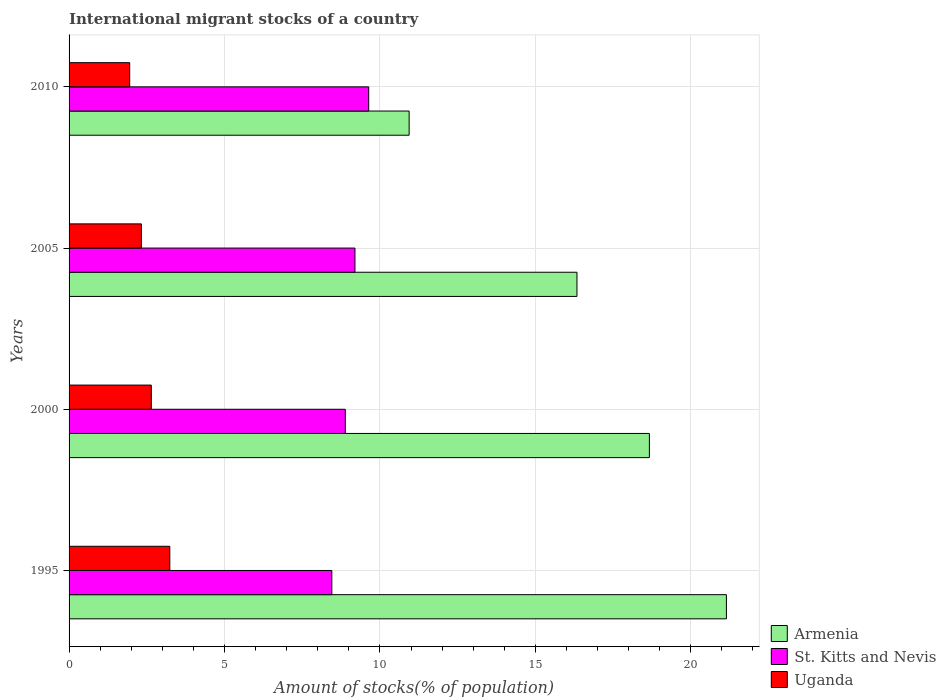How many different coloured bars are there?
Keep it short and to the point. 3. Are the number of bars per tick equal to the number of legend labels?
Keep it short and to the point. Yes. Are the number of bars on each tick of the Y-axis equal?
Provide a short and direct response. Yes. How many bars are there on the 3rd tick from the top?
Your answer should be very brief. 3. How many bars are there on the 3rd tick from the bottom?
Offer a very short reply. 3. What is the amount of stocks in in St. Kitts and Nevis in 1995?
Your answer should be very brief. 8.45. Across all years, what is the maximum amount of stocks in in St. Kitts and Nevis?
Offer a very short reply. 9.64. Across all years, what is the minimum amount of stocks in in Uganda?
Your response must be concise. 1.95. In which year was the amount of stocks in in Armenia minimum?
Give a very brief answer. 2010. What is the total amount of stocks in in St. Kitts and Nevis in the graph?
Offer a terse response. 36.17. What is the difference between the amount of stocks in in St. Kitts and Nevis in 2000 and that in 2010?
Keep it short and to the point. -0.75. What is the difference between the amount of stocks in in St. Kitts and Nevis in 2005 and the amount of stocks in in Uganda in 1995?
Give a very brief answer. 5.96. What is the average amount of stocks in in Armenia per year?
Your answer should be very brief. 16.77. In the year 1995, what is the difference between the amount of stocks in in Armenia and amount of stocks in in St. Kitts and Nevis?
Your answer should be compact. 12.69. What is the ratio of the amount of stocks in in St. Kitts and Nevis in 2005 to that in 2010?
Give a very brief answer. 0.95. Is the amount of stocks in in Armenia in 2005 less than that in 2010?
Provide a short and direct response. No. Is the difference between the amount of stocks in in Armenia in 2000 and 2005 greater than the difference between the amount of stocks in in St. Kitts and Nevis in 2000 and 2005?
Your response must be concise. Yes. What is the difference between the highest and the second highest amount of stocks in in St. Kitts and Nevis?
Give a very brief answer. 0.44. What is the difference between the highest and the lowest amount of stocks in in Armenia?
Your answer should be very brief. 10.21. In how many years, is the amount of stocks in in Armenia greater than the average amount of stocks in in Armenia taken over all years?
Your answer should be compact. 2. Is the sum of the amount of stocks in in St. Kitts and Nevis in 1995 and 2000 greater than the maximum amount of stocks in in Uganda across all years?
Provide a short and direct response. Yes. What does the 1st bar from the top in 2010 represents?
Provide a short and direct response. Uganda. What does the 2nd bar from the bottom in 1995 represents?
Provide a succinct answer. St. Kitts and Nevis. How many bars are there?
Keep it short and to the point. 12. How many years are there in the graph?
Give a very brief answer. 4. Are the values on the major ticks of X-axis written in scientific E-notation?
Your answer should be compact. No. Does the graph contain any zero values?
Offer a very short reply. No. Where does the legend appear in the graph?
Offer a terse response. Bottom right. How many legend labels are there?
Provide a short and direct response. 3. How are the legend labels stacked?
Your answer should be very brief. Vertical. What is the title of the graph?
Make the answer very short. International migrant stocks of a country. Does "Low income" appear as one of the legend labels in the graph?
Give a very brief answer. No. What is the label or title of the X-axis?
Keep it short and to the point. Amount of stocks(% of population). What is the Amount of stocks(% of population) of Armenia in 1995?
Provide a succinct answer. 21.15. What is the Amount of stocks(% of population) of St. Kitts and Nevis in 1995?
Give a very brief answer. 8.45. What is the Amount of stocks(% of population) of Uganda in 1995?
Keep it short and to the point. 3.24. What is the Amount of stocks(% of population) of Armenia in 2000?
Your answer should be very brief. 18.67. What is the Amount of stocks(% of population) in St. Kitts and Nevis in 2000?
Offer a terse response. 8.89. What is the Amount of stocks(% of population) of Uganda in 2000?
Offer a very short reply. 2.65. What is the Amount of stocks(% of population) of Armenia in 2005?
Keep it short and to the point. 16.34. What is the Amount of stocks(% of population) in St. Kitts and Nevis in 2005?
Make the answer very short. 9.2. What is the Amount of stocks(% of population) in Uganda in 2005?
Make the answer very short. 2.33. What is the Amount of stocks(% of population) in Armenia in 2010?
Your answer should be compact. 10.94. What is the Amount of stocks(% of population) of St. Kitts and Nevis in 2010?
Your answer should be compact. 9.64. What is the Amount of stocks(% of population) of Uganda in 2010?
Keep it short and to the point. 1.95. Across all years, what is the maximum Amount of stocks(% of population) of Armenia?
Your response must be concise. 21.15. Across all years, what is the maximum Amount of stocks(% of population) of St. Kitts and Nevis?
Provide a succinct answer. 9.64. Across all years, what is the maximum Amount of stocks(% of population) in Uganda?
Make the answer very short. 3.24. Across all years, what is the minimum Amount of stocks(% of population) in Armenia?
Keep it short and to the point. 10.94. Across all years, what is the minimum Amount of stocks(% of population) in St. Kitts and Nevis?
Give a very brief answer. 8.45. Across all years, what is the minimum Amount of stocks(% of population) in Uganda?
Ensure brevity in your answer.  1.95. What is the total Amount of stocks(% of population) in Armenia in the graph?
Offer a very short reply. 67.09. What is the total Amount of stocks(% of population) of St. Kitts and Nevis in the graph?
Your response must be concise. 36.17. What is the total Amount of stocks(% of population) of Uganda in the graph?
Ensure brevity in your answer.  10.16. What is the difference between the Amount of stocks(% of population) of Armenia in 1995 and that in 2000?
Keep it short and to the point. 2.48. What is the difference between the Amount of stocks(% of population) of St. Kitts and Nevis in 1995 and that in 2000?
Ensure brevity in your answer.  -0.43. What is the difference between the Amount of stocks(% of population) in Uganda in 1995 and that in 2000?
Ensure brevity in your answer.  0.6. What is the difference between the Amount of stocks(% of population) of Armenia in 1995 and that in 2005?
Make the answer very short. 4.81. What is the difference between the Amount of stocks(% of population) of St. Kitts and Nevis in 1995 and that in 2005?
Your response must be concise. -0.74. What is the difference between the Amount of stocks(% of population) of Uganda in 1995 and that in 2005?
Make the answer very short. 0.91. What is the difference between the Amount of stocks(% of population) of Armenia in 1995 and that in 2010?
Ensure brevity in your answer.  10.21. What is the difference between the Amount of stocks(% of population) of St. Kitts and Nevis in 1995 and that in 2010?
Your response must be concise. -1.19. What is the difference between the Amount of stocks(% of population) of Uganda in 1995 and that in 2010?
Keep it short and to the point. 1.29. What is the difference between the Amount of stocks(% of population) in Armenia in 2000 and that in 2005?
Offer a very short reply. 2.33. What is the difference between the Amount of stocks(% of population) of St. Kitts and Nevis in 2000 and that in 2005?
Make the answer very short. -0.31. What is the difference between the Amount of stocks(% of population) in Uganda in 2000 and that in 2005?
Make the answer very short. 0.32. What is the difference between the Amount of stocks(% of population) of Armenia in 2000 and that in 2010?
Your response must be concise. 7.73. What is the difference between the Amount of stocks(% of population) in St. Kitts and Nevis in 2000 and that in 2010?
Provide a succinct answer. -0.75. What is the difference between the Amount of stocks(% of population) in Uganda in 2000 and that in 2010?
Provide a short and direct response. 0.69. What is the difference between the Amount of stocks(% of population) in Armenia in 2005 and that in 2010?
Give a very brief answer. 5.4. What is the difference between the Amount of stocks(% of population) in St. Kitts and Nevis in 2005 and that in 2010?
Your response must be concise. -0.44. What is the difference between the Amount of stocks(% of population) of Uganda in 2005 and that in 2010?
Offer a terse response. 0.38. What is the difference between the Amount of stocks(% of population) of Armenia in 1995 and the Amount of stocks(% of population) of St. Kitts and Nevis in 2000?
Provide a short and direct response. 12.26. What is the difference between the Amount of stocks(% of population) of Armenia in 1995 and the Amount of stocks(% of population) of Uganda in 2000?
Provide a short and direct response. 18.5. What is the difference between the Amount of stocks(% of population) in St. Kitts and Nevis in 1995 and the Amount of stocks(% of population) in Uganda in 2000?
Keep it short and to the point. 5.81. What is the difference between the Amount of stocks(% of population) in Armenia in 1995 and the Amount of stocks(% of population) in St. Kitts and Nevis in 2005?
Offer a terse response. 11.95. What is the difference between the Amount of stocks(% of population) in Armenia in 1995 and the Amount of stocks(% of population) in Uganda in 2005?
Make the answer very short. 18.82. What is the difference between the Amount of stocks(% of population) of St. Kitts and Nevis in 1995 and the Amount of stocks(% of population) of Uganda in 2005?
Your answer should be very brief. 6.13. What is the difference between the Amount of stocks(% of population) in Armenia in 1995 and the Amount of stocks(% of population) in St. Kitts and Nevis in 2010?
Your answer should be compact. 11.51. What is the difference between the Amount of stocks(% of population) of Armenia in 1995 and the Amount of stocks(% of population) of Uganda in 2010?
Offer a terse response. 19.2. What is the difference between the Amount of stocks(% of population) in St. Kitts and Nevis in 1995 and the Amount of stocks(% of population) in Uganda in 2010?
Offer a terse response. 6.5. What is the difference between the Amount of stocks(% of population) in Armenia in 2000 and the Amount of stocks(% of population) in St. Kitts and Nevis in 2005?
Your answer should be very brief. 9.47. What is the difference between the Amount of stocks(% of population) of Armenia in 2000 and the Amount of stocks(% of population) of Uganda in 2005?
Provide a short and direct response. 16.34. What is the difference between the Amount of stocks(% of population) in St. Kitts and Nevis in 2000 and the Amount of stocks(% of population) in Uganda in 2005?
Offer a terse response. 6.56. What is the difference between the Amount of stocks(% of population) of Armenia in 2000 and the Amount of stocks(% of population) of St. Kitts and Nevis in 2010?
Offer a terse response. 9.03. What is the difference between the Amount of stocks(% of population) of Armenia in 2000 and the Amount of stocks(% of population) of Uganda in 2010?
Your answer should be compact. 16.72. What is the difference between the Amount of stocks(% of population) of St. Kitts and Nevis in 2000 and the Amount of stocks(% of population) of Uganda in 2010?
Your answer should be very brief. 6.94. What is the difference between the Amount of stocks(% of population) of Armenia in 2005 and the Amount of stocks(% of population) of St. Kitts and Nevis in 2010?
Make the answer very short. 6.7. What is the difference between the Amount of stocks(% of population) of Armenia in 2005 and the Amount of stocks(% of population) of Uganda in 2010?
Make the answer very short. 14.39. What is the difference between the Amount of stocks(% of population) of St. Kitts and Nevis in 2005 and the Amount of stocks(% of population) of Uganda in 2010?
Keep it short and to the point. 7.25. What is the average Amount of stocks(% of population) in Armenia per year?
Provide a succinct answer. 16.77. What is the average Amount of stocks(% of population) of St. Kitts and Nevis per year?
Make the answer very short. 9.04. What is the average Amount of stocks(% of population) in Uganda per year?
Make the answer very short. 2.54. In the year 1995, what is the difference between the Amount of stocks(% of population) in Armenia and Amount of stocks(% of population) in St. Kitts and Nevis?
Your answer should be very brief. 12.69. In the year 1995, what is the difference between the Amount of stocks(% of population) of Armenia and Amount of stocks(% of population) of Uganda?
Provide a short and direct response. 17.91. In the year 1995, what is the difference between the Amount of stocks(% of population) in St. Kitts and Nevis and Amount of stocks(% of population) in Uganda?
Offer a very short reply. 5.21. In the year 2000, what is the difference between the Amount of stocks(% of population) in Armenia and Amount of stocks(% of population) in St. Kitts and Nevis?
Provide a succinct answer. 9.78. In the year 2000, what is the difference between the Amount of stocks(% of population) of Armenia and Amount of stocks(% of population) of Uganda?
Provide a succinct answer. 16.02. In the year 2000, what is the difference between the Amount of stocks(% of population) in St. Kitts and Nevis and Amount of stocks(% of population) in Uganda?
Your response must be concise. 6.24. In the year 2005, what is the difference between the Amount of stocks(% of population) in Armenia and Amount of stocks(% of population) in St. Kitts and Nevis?
Ensure brevity in your answer.  7.14. In the year 2005, what is the difference between the Amount of stocks(% of population) of Armenia and Amount of stocks(% of population) of Uganda?
Your answer should be compact. 14.01. In the year 2005, what is the difference between the Amount of stocks(% of population) of St. Kitts and Nevis and Amount of stocks(% of population) of Uganda?
Your answer should be very brief. 6.87. In the year 2010, what is the difference between the Amount of stocks(% of population) of Armenia and Amount of stocks(% of population) of St. Kitts and Nevis?
Keep it short and to the point. 1.3. In the year 2010, what is the difference between the Amount of stocks(% of population) in Armenia and Amount of stocks(% of population) in Uganda?
Provide a succinct answer. 8.99. In the year 2010, what is the difference between the Amount of stocks(% of population) in St. Kitts and Nevis and Amount of stocks(% of population) in Uganda?
Provide a succinct answer. 7.69. What is the ratio of the Amount of stocks(% of population) in Armenia in 1995 to that in 2000?
Ensure brevity in your answer.  1.13. What is the ratio of the Amount of stocks(% of population) in St. Kitts and Nevis in 1995 to that in 2000?
Offer a very short reply. 0.95. What is the ratio of the Amount of stocks(% of population) in Uganda in 1995 to that in 2000?
Ensure brevity in your answer.  1.23. What is the ratio of the Amount of stocks(% of population) in Armenia in 1995 to that in 2005?
Your response must be concise. 1.29. What is the ratio of the Amount of stocks(% of population) in St. Kitts and Nevis in 1995 to that in 2005?
Your answer should be compact. 0.92. What is the ratio of the Amount of stocks(% of population) of Uganda in 1995 to that in 2005?
Your answer should be very brief. 1.39. What is the ratio of the Amount of stocks(% of population) in Armenia in 1995 to that in 2010?
Make the answer very short. 1.93. What is the ratio of the Amount of stocks(% of population) of St. Kitts and Nevis in 1995 to that in 2010?
Offer a very short reply. 0.88. What is the ratio of the Amount of stocks(% of population) of Uganda in 1995 to that in 2010?
Ensure brevity in your answer.  1.66. What is the ratio of the Amount of stocks(% of population) of Armenia in 2000 to that in 2005?
Offer a terse response. 1.14. What is the ratio of the Amount of stocks(% of population) of St. Kitts and Nevis in 2000 to that in 2005?
Ensure brevity in your answer.  0.97. What is the ratio of the Amount of stocks(% of population) in Uganda in 2000 to that in 2005?
Ensure brevity in your answer.  1.14. What is the ratio of the Amount of stocks(% of population) of Armenia in 2000 to that in 2010?
Make the answer very short. 1.71. What is the ratio of the Amount of stocks(% of population) in St. Kitts and Nevis in 2000 to that in 2010?
Make the answer very short. 0.92. What is the ratio of the Amount of stocks(% of population) in Uganda in 2000 to that in 2010?
Provide a succinct answer. 1.36. What is the ratio of the Amount of stocks(% of population) of Armenia in 2005 to that in 2010?
Make the answer very short. 1.49. What is the ratio of the Amount of stocks(% of population) in St. Kitts and Nevis in 2005 to that in 2010?
Make the answer very short. 0.95. What is the ratio of the Amount of stocks(% of population) of Uganda in 2005 to that in 2010?
Give a very brief answer. 1.19. What is the difference between the highest and the second highest Amount of stocks(% of population) of Armenia?
Give a very brief answer. 2.48. What is the difference between the highest and the second highest Amount of stocks(% of population) in St. Kitts and Nevis?
Keep it short and to the point. 0.44. What is the difference between the highest and the second highest Amount of stocks(% of population) in Uganda?
Offer a terse response. 0.6. What is the difference between the highest and the lowest Amount of stocks(% of population) of Armenia?
Offer a terse response. 10.21. What is the difference between the highest and the lowest Amount of stocks(% of population) of St. Kitts and Nevis?
Your answer should be very brief. 1.19. What is the difference between the highest and the lowest Amount of stocks(% of population) in Uganda?
Offer a terse response. 1.29. 